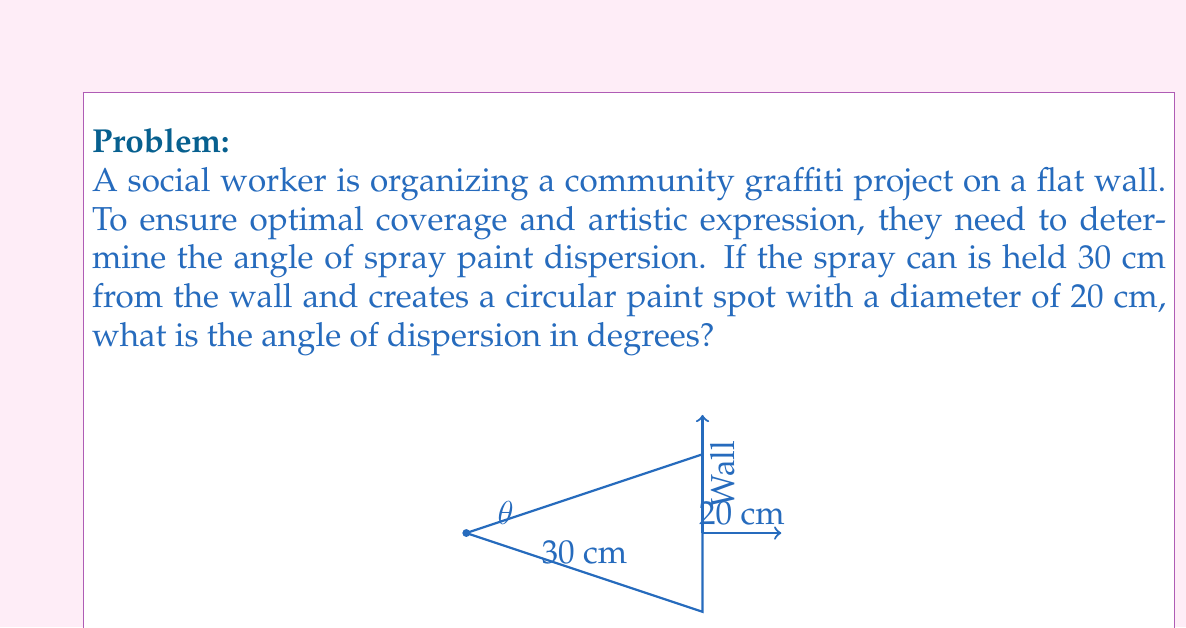Can you solve this math problem? Let's approach this step-by-step:

1) The spray paint forms a cone, with the tip at the nozzle and the base on the wall. We need to find the angle at the tip of this cone.

2) We can split this cone into two right triangles. The angle we're looking for is twice the angle in one of these triangles.

3) In one of these right triangles:
   - The adjacent side is the distance from the nozzle to the wall: 30 cm
   - The opposite side is half the diameter of the paint spot: 10 cm (20 cm ÷ 2)

4) We can use the tangent function to find half of our angle:

   $$\tan(\frac{\theta}{2}) = \frac{\text{opposite}}{\text{adjacent}} = \frac{10}{30} = \frac{1}{3}$$

5) To solve for $\frac{\theta}{2}$, we use the inverse tangent (arctan or $\tan^{-1}$):

   $$\frac{\theta}{2} = \tan^{-1}(\frac{1}{3})$$

6) Using a calculator or trigonometric tables, we find:

   $$\frac{\theta}{2} \approx 18.43^\circ$$

7) Since this is half our angle, we multiply by 2:

   $$\theta \approx 18.43^\circ \times 2 = 36.86^\circ$$

8) Rounding to two decimal places:

   $$\theta \approx 36.87^\circ$$

This angle of dispersion will provide optimal coverage for the graffiti project, allowing for effective self-expression through spray paint art.
Answer: $36.87^\circ$ 